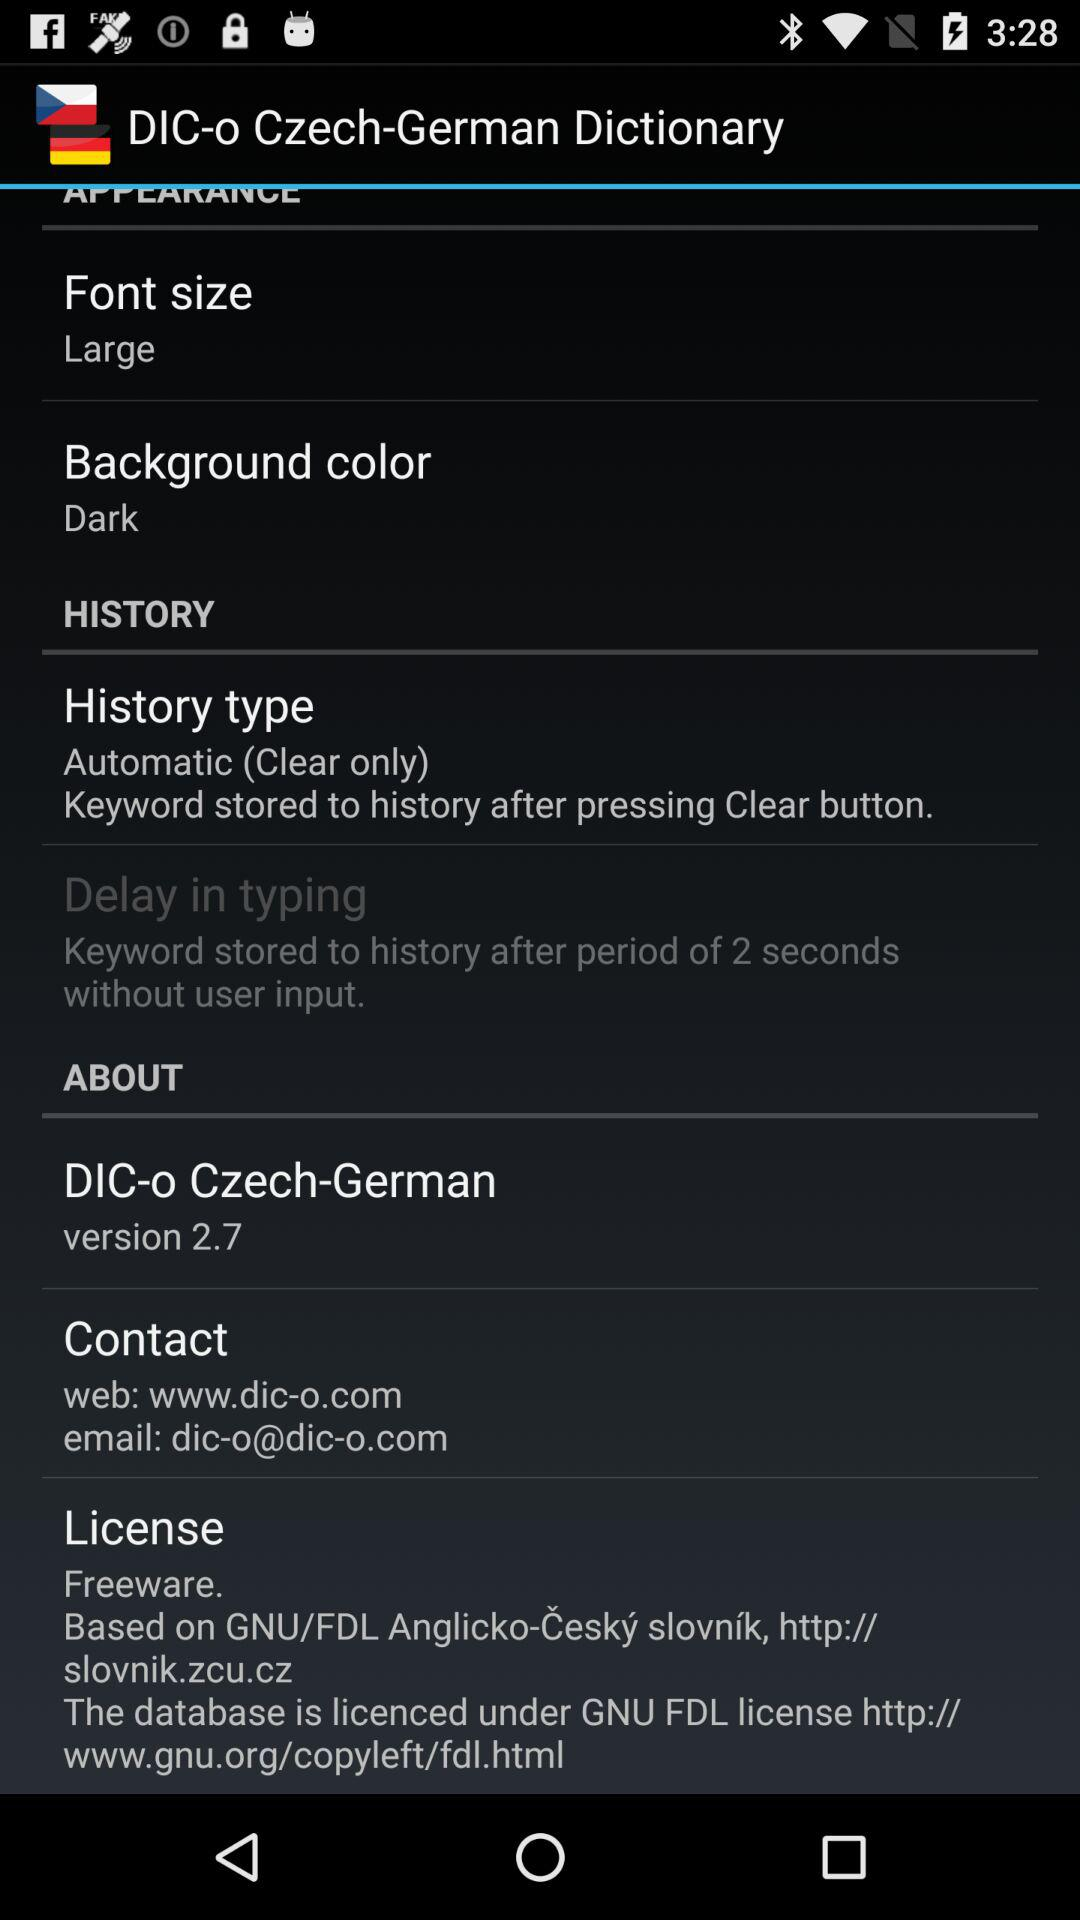What is the font size? The font size is large. 